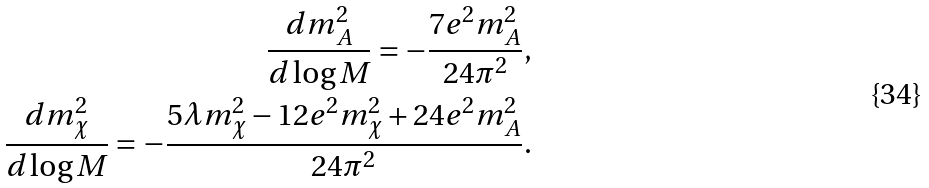Convert formula to latex. <formula><loc_0><loc_0><loc_500><loc_500>\frac { d m _ { A } ^ { 2 } } { d \log M } = - \frac { 7 e ^ { 2 } m _ { A } ^ { 2 } } { 2 4 \pi ^ { 2 } } , \\ \frac { d m _ { \chi } ^ { 2 } } { d \log M } = - \frac { 5 \lambda m _ { \chi } ^ { 2 } - 1 2 e ^ { 2 } m _ { \chi } ^ { 2 } + 2 4 e ^ { 2 } m _ { A } ^ { 2 } } { 2 4 \pi ^ { 2 } } .</formula> 